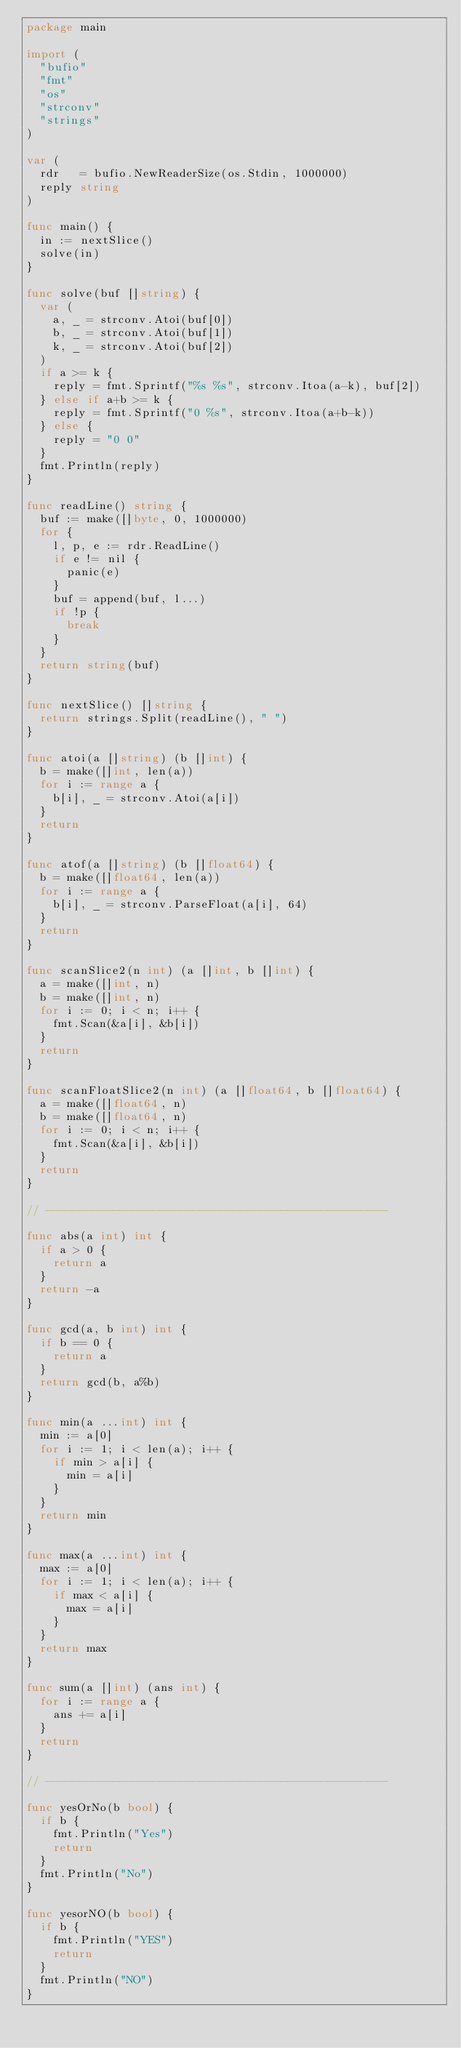<code> <loc_0><loc_0><loc_500><loc_500><_Go_>package main

import (
	"bufio"
	"fmt"
	"os"
	"strconv"
	"strings"
)

var (
	rdr   = bufio.NewReaderSize(os.Stdin, 1000000)
	reply string
)

func main() {
	in := nextSlice()
	solve(in)
}

func solve(buf []string) {
	var (
		a, _ = strconv.Atoi(buf[0])
		b, _ = strconv.Atoi(buf[1])
		k, _ = strconv.Atoi(buf[2])
	)
	if a >= k {
		reply = fmt.Sprintf("%s %s", strconv.Itoa(a-k), buf[2])
	} else if a+b >= k {
		reply = fmt.Sprintf("0 %s", strconv.Itoa(a+b-k))
	} else {
		reply = "0 0"
	}
	fmt.Println(reply)
}

func readLine() string {
	buf := make([]byte, 0, 1000000)
	for {
		l, p, e := rdr.ReadLine()
		if e != nil {
			panic(e)
		}
		buf = append(buf, l...)
		if !p {
			break
		}
	}
	return string(buf)
}

func nextSlice() []string {
	return strings.Split(readLine(), " ")
}

func atoi(a []string) (b []int) {
	b = make([]int, len(a))
	for i := range a {
		b[i], _ = strconv.Atoi(a[i])
	}
	return
}

func atof(a []string) (b []float64) {
	b = make([]float64, len(a))
	for i := range a {
		b[i], _ = strconv.ParseFloat(a[i], 64)
	}
	return
}

func scanSlice2(n int) (a []int, b []int) {
	a = make([]int, n)
	b = make([]int, n)
	for i := 0; i < n; i++ {
		fmt.Scan(&a[i], &b[i])
	}
	return
}

func scanFloatSlice2(n int) (a []float64, b []float64) {
	a = make([]float64, n)
	b = make([]float64, n)
	for i := 0; i < n; i++ {
		fmt.Scan(&a[i], &b[i])
	}
	return
}

// ---------------------------------------------------

func abs(a int) int {
	if a > 0 {
		return a
	}
	return -a
}

func gcd(a, b int) int {
	if b == 0 {
		return a
	}
	return gcd(b, a%b)
}

func min(a ...int) int {
	min := a[0]
	for i := 1; i < len(a); i++ {
		if min > a[i] {
			min = a[i]
		}
	}
	return min
}

func max(a ...int) int {
	max := a[0]
	for i := 1; i < len(a); i++ {
		if max < a[i] {
			max = a[i]
		}
	}
	return max
}

func sum(a []int) (ans int) {
	for i := range a {
		ans += a[i]
	}
	return
}

// ---------------------------------------------------

func yesOrNo(b bool) {
	if b {
		fmt.Println("Yes")
		return
	}
	fmt.Println("No")
}

func yesorNO(b bool) {
	if b {
		fmt.Println("YES")
		return
	}
	fmt.Println("NO")
}</code> 